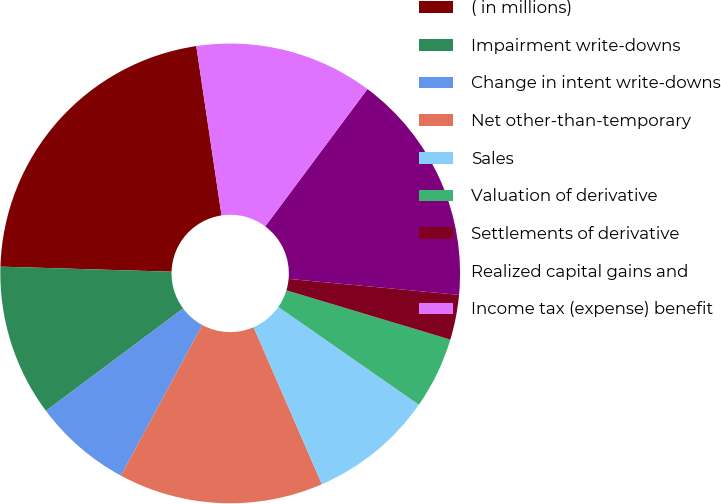<chart> <loc_0><loc_0><loc_500><loc_500><pie_chart><fcel>( in millions)<fcel>Impairment write-downs<fcel>Change in intent write-downs<fcel>Net other-than-temporary<fcel>Sales<fcel>Valuation of derivative<fcel>Settlements of derivative<fcel>Realized capital gains and<fcel>Income tax (expense) benefit<nl><fcel>22.17%<fcel>10.67%<fcel>6.91%<fcel>14.42%<fcel>8.79%<fcel>5.03%<fcel>3.16%<fcel>16.3%<fcel>12.54%<nl></chart> 